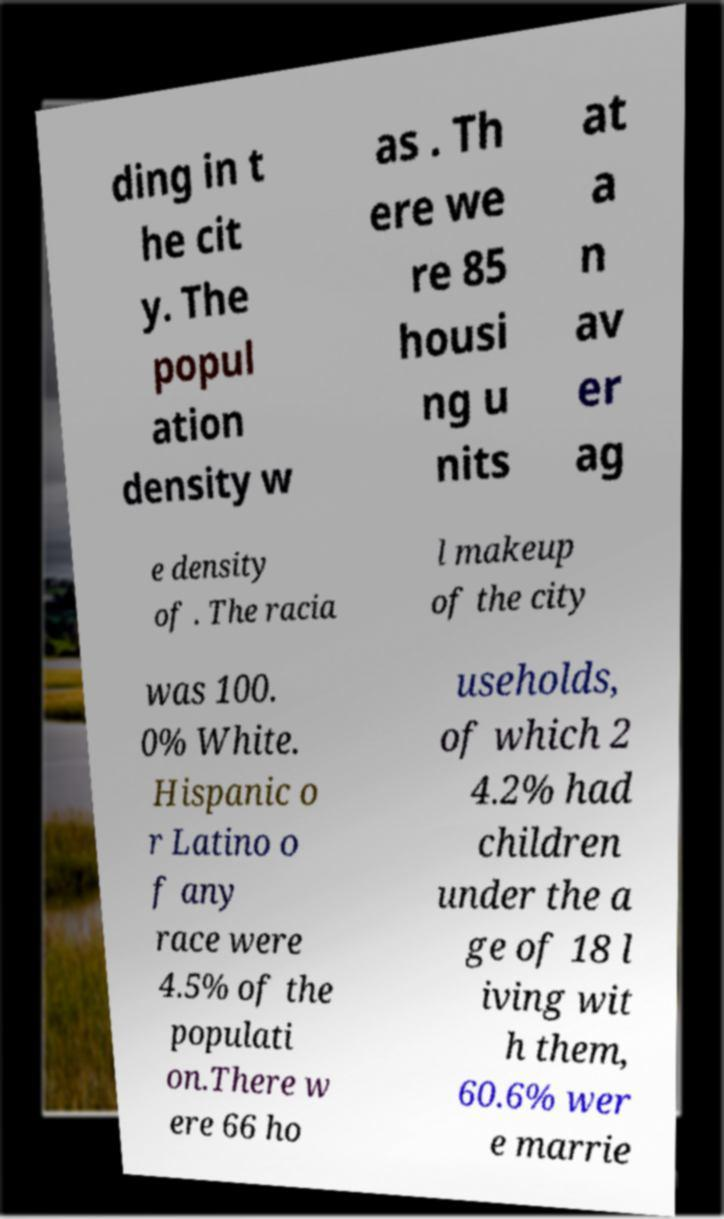I need the written content from this picture converted into text. Can you do that? ding in t he cit y. The popul ation density w as . Th ere we re 85 housi ng u nits at a n av er ag e density of . The racia l makeup of the city was 100. 0% White. Hispanic o r Latino o f any race were 4.5% of the populati on.There w ere 66 ho useholds, of which 2 4.2% had children under the a ge of 18 l iving wit h them, 60.6% wer e marrie 